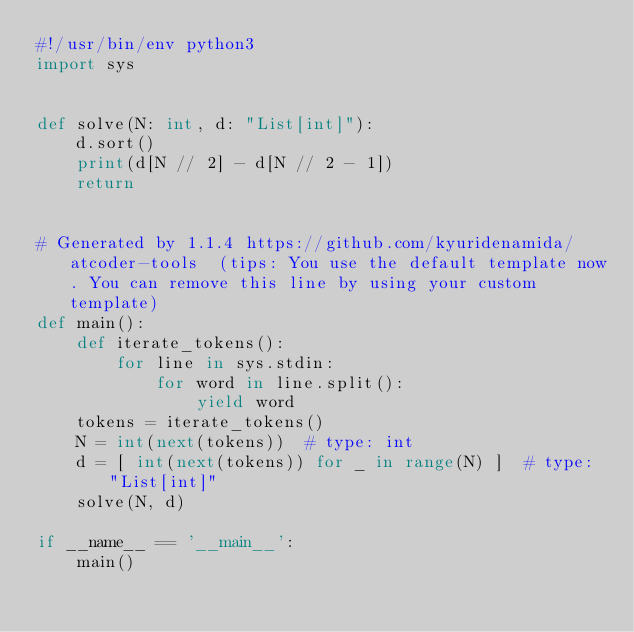Convert code to text. <code><loc_0><loc_0><loc_500><loc_500><_Python_>#!/usr/bin/env python3
import sys


def solve(N: int, d: "List[int]"):
    d.sort()
    print(d[N // 2] - d[N // 2 - 1])
    return


# Generated by 1.1.4 https://github.com/kyuridenamida/atcoder-tools  (tips: You use the default template now. You can remove this line by using your custom template)
def main():
    def iterate_tokens():
        for line in sys.stdin:
            for word in line.split():
                yield word
    tokens = iterate_tokens()
    N = int(next(tokens))  # type: int
    d = [ int(next(tokens)) for _ in range(N) ]  # type: "List[int]"
    solve(N, d)

if __name__ == '__main__':
    main()
</code> 